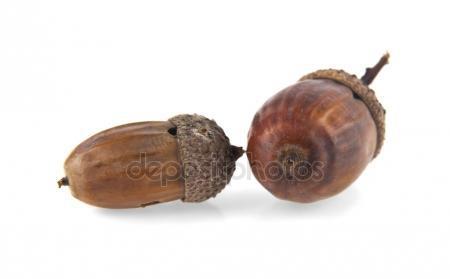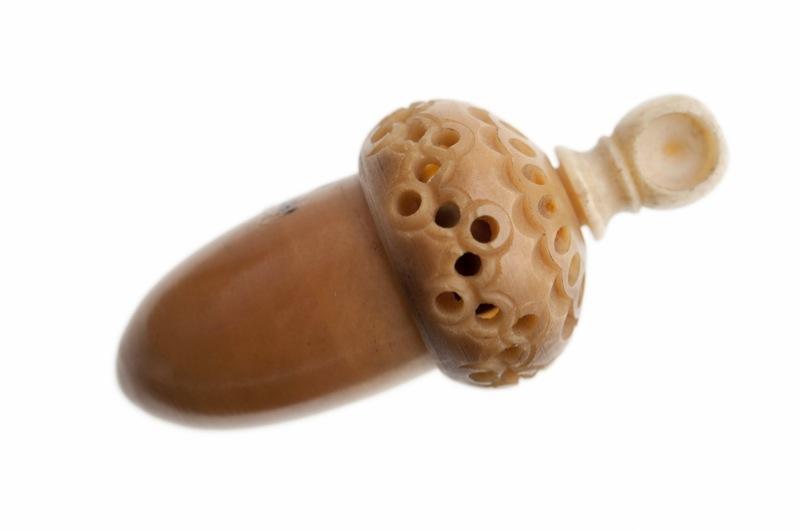The first image is the image on the left, the second image is the image on the right. Considering the images on both sides, is "There are four acorns with brown tops." valid? Answer yes or no. No. The first image is the image on the left, the second image is the image on the right. Analyze the images presented: Is the assertion "Each image contains one pair of acorns with their caps on, and no image contains a leaf." valid? Answer yes or no. No. 